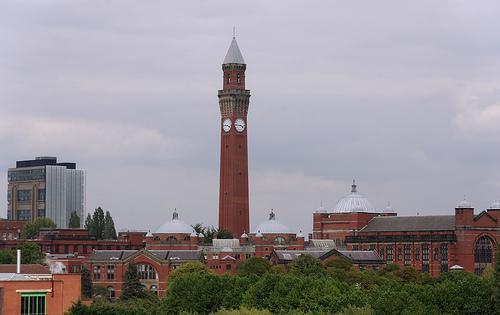How many building have round tops?
Give a very brief answer. 3. 